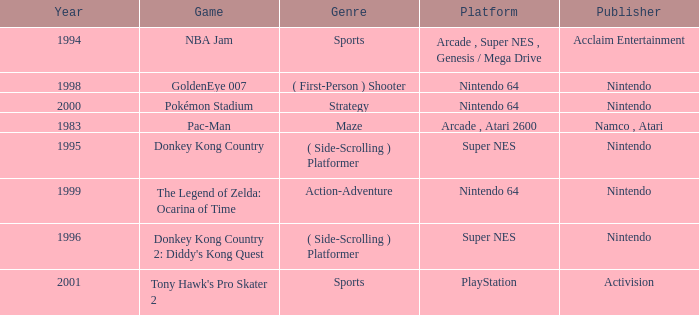Which Genre has a Game of donkey kong country? ( Side-Scrolling ) Platformer. 